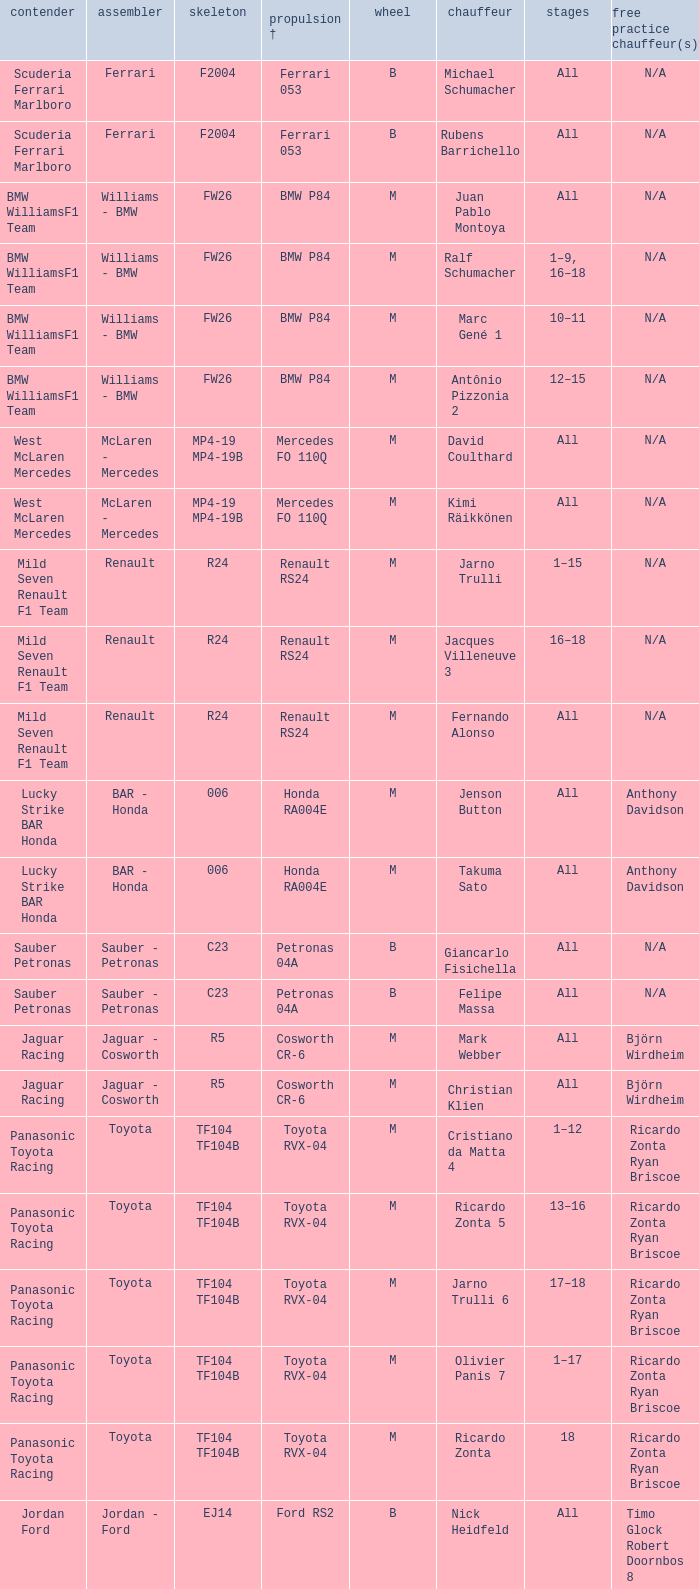What kind of chassis does Ricardo Zonta have? TF104 TF104B. 